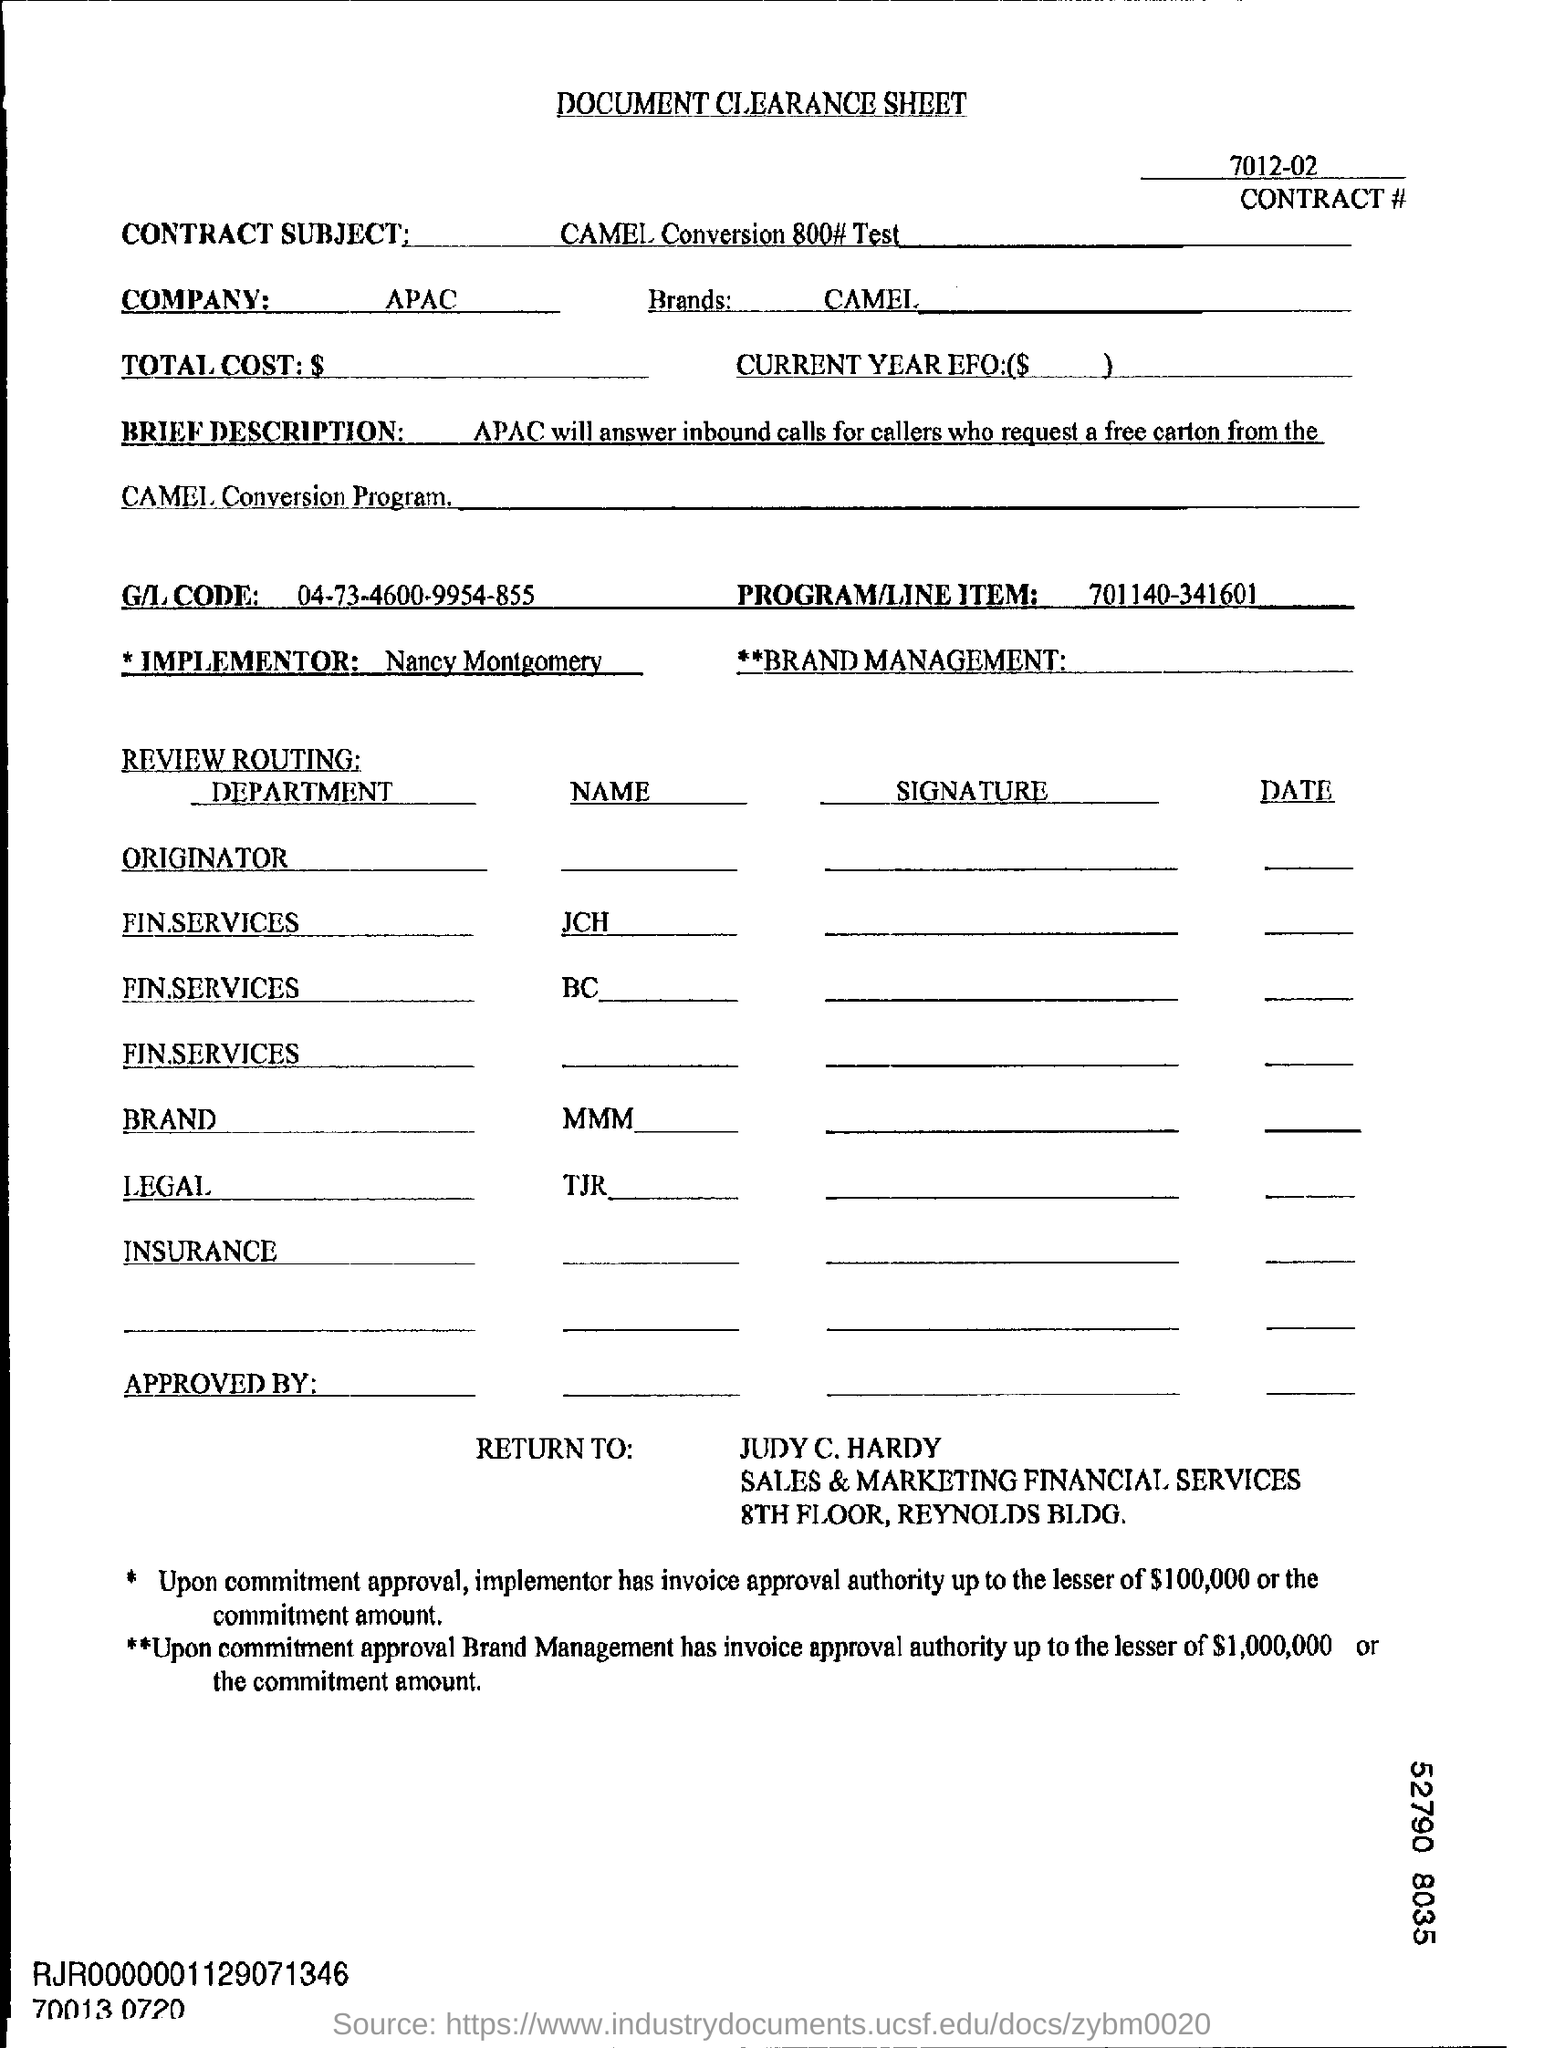Highlight a few significant elements in this photo. The company name is APAC, and it is located in the APAC region. The Program/Line Item Filed mentions the following: 701140-341601. 